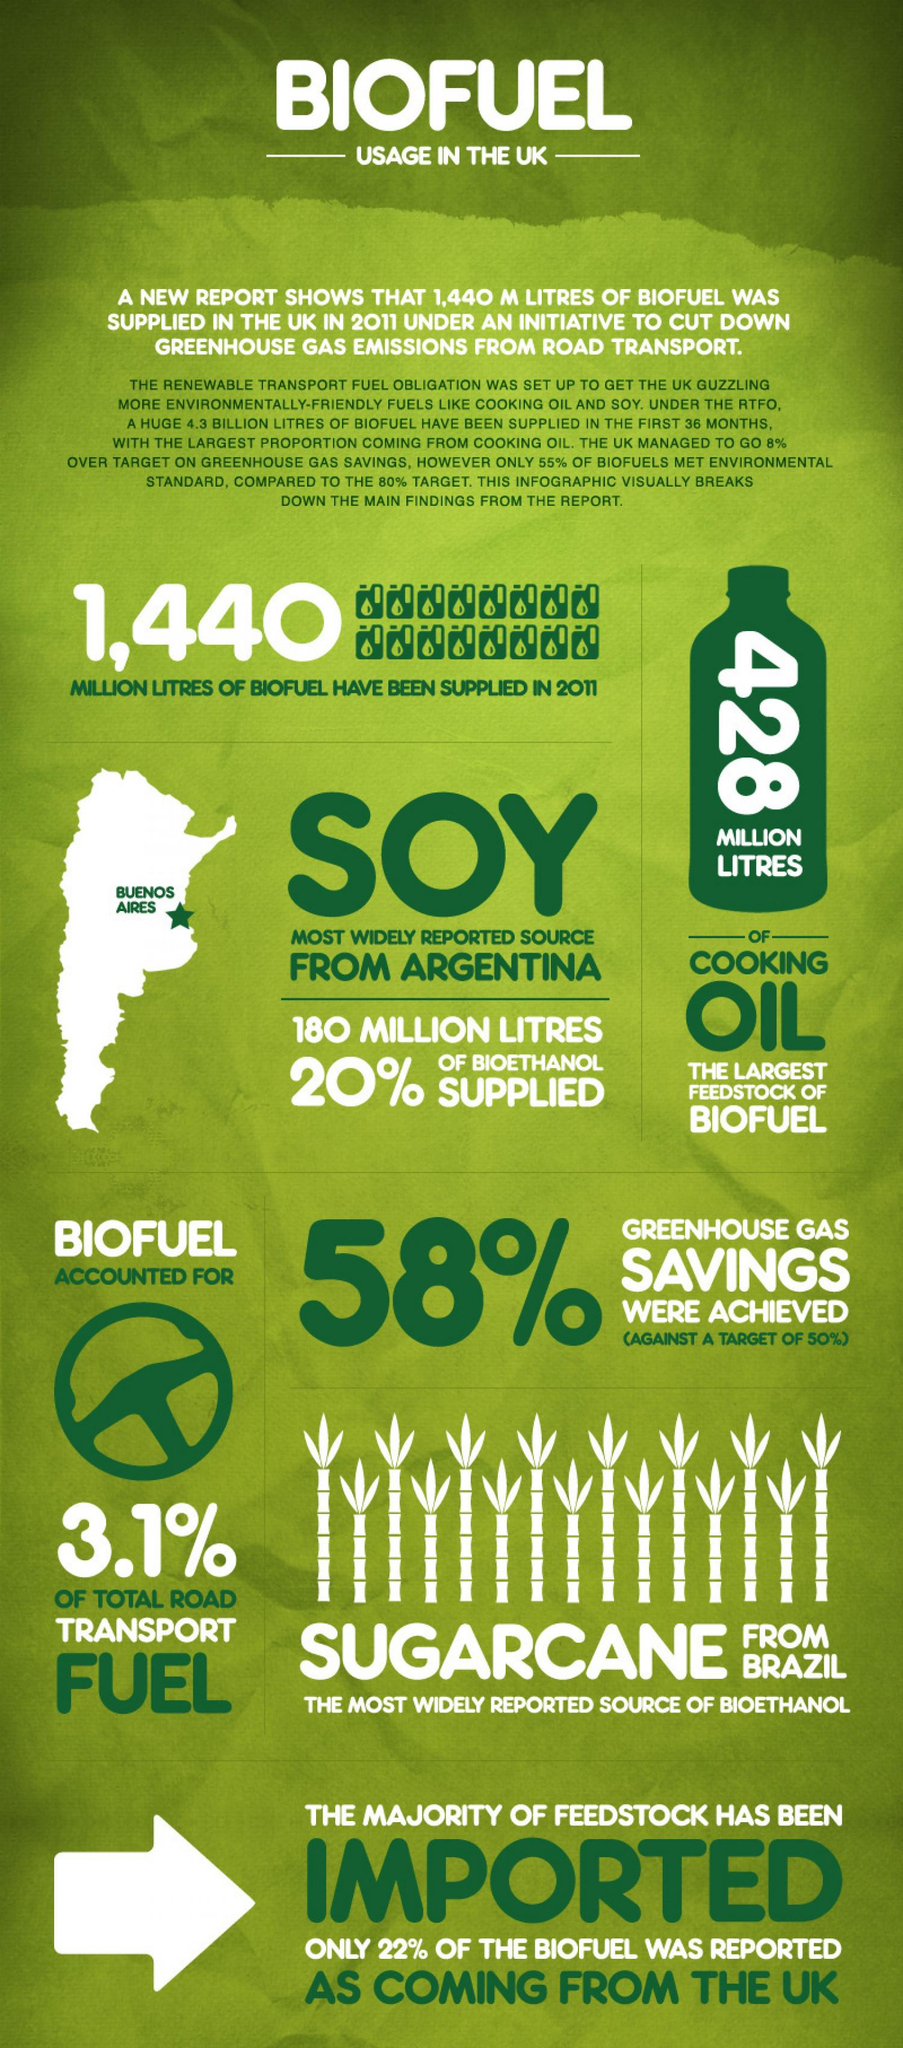List a handful of essential elements in this visual. The color of the arrow symbol is white. Bioethanol, which is a renewable energy source, is primarily derived from sugarcane. The UK has imported 78% of its biofuel needs. The infographic contains the number "1440" and the task is to find the count of this number. The number written vertically on the green bottle in the vector image is 428. 